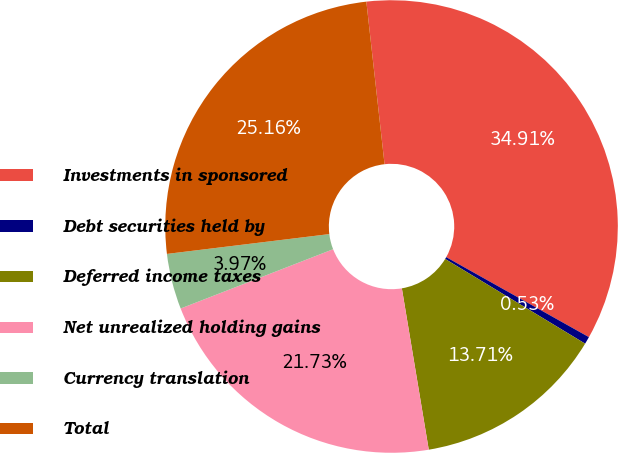Convert chart to OTSL. <chart><loc_0><loc_0><loc_500><loc_500><pie_chart><fcel>Investments in sponsored<fcel>Debt securities held by<fcel>Deferred income taxes<fcel>Net unrealized holding gains<fcel>Currency translation<fcel>Total<nl><fcel>34.91%<fcel>0.53%<fcel>13.71%<fcel>21.73%<fcel>3.97%<fcel>25.16%<nl></chart> 